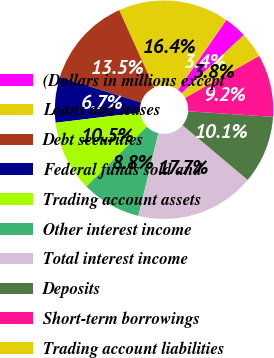<chart> <loc_0><loc_0><loc_500><loc_500><pie_chart><fcel>(Dollars in millions except<fcel>Loans and leases<fcel>Debt securities<fcel>Federal funds sold and<fcel>Trading account assets<fcel>Other interest income<fcel>Total interest income<fcel>Deposits<fcel>Short-term borrowings<fcel>Trading account liabilities<nl><fcel>3.36%<fcel>16.39%<fcel>13.45%<fcel>6.72%<fcel>10.5%<fcel>8.82%<fcel>17.65%<fcel>10.08%<fcel>9.24%<fcel>3.78%<nl></chart> 